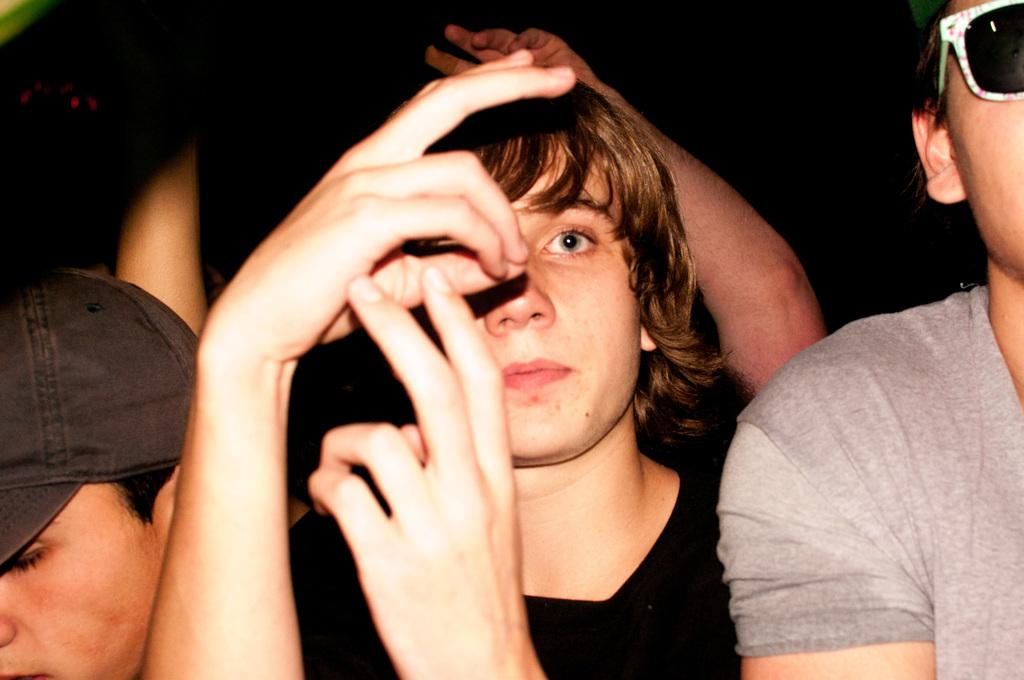How many people are in the image? There are people in the image. Can you describe the appearance of one of the individuals? One person is wearing glasses on the right side. What is another person wearing in the image? Another person is wearing a cap on the left side. How many clovers are visible in the image? There are no clovers present in the image. What type of camera is being used by the person on the left side? There is no camera visible in the image. 